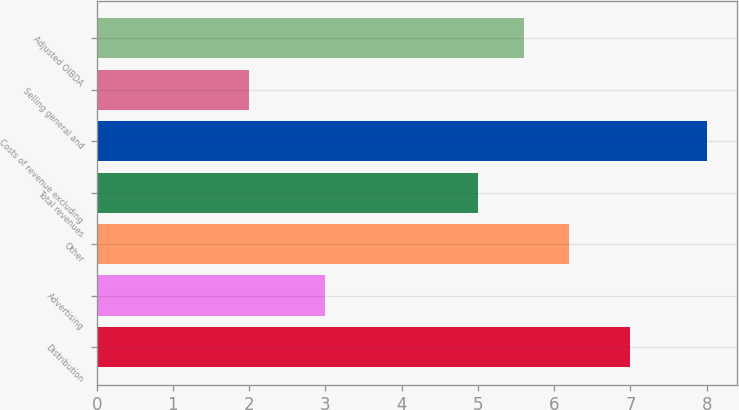Convert chart to OTSL. <chart><loc_0><loc_0><loc_500><loc_500><bar_chart><fcel>Distribution<fcel>Advertising<fcel>Other<fcel>Total revenues<fcel>Costs of revenue excluding<fcel>Selling general and<fcel>Adjusted OIBDA<nl><fcel>7<fcel>3<fcel>6.2<fcel>5<fcel>8<fcel>2<fcel>5.6<nl></chart> 